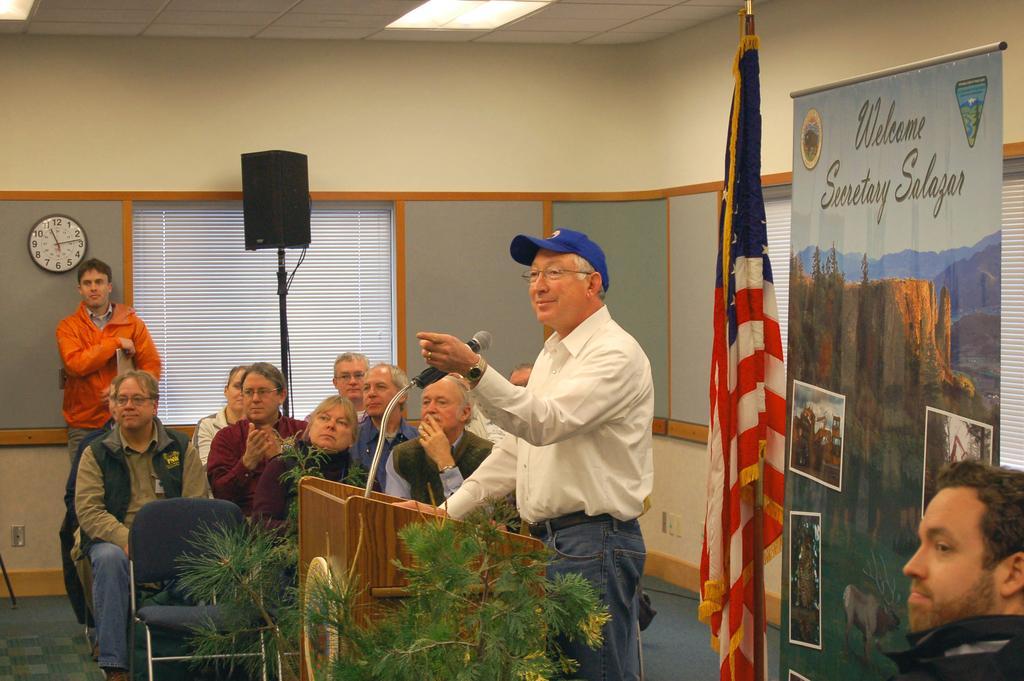Could you give a brief overview of what you see in this image? In this picture I can see few people are sitting in the chairs and a man standing and speaking with the help of a microphone and I can see a podium and a plant and I can see another man standing on the left side and I can see a speaker to the stand and wall clock and I can see a flag and advertisement hoarding with some text and pictures and I can see another man seated on the right side of the picture and I can see few lights on the ceiling. 